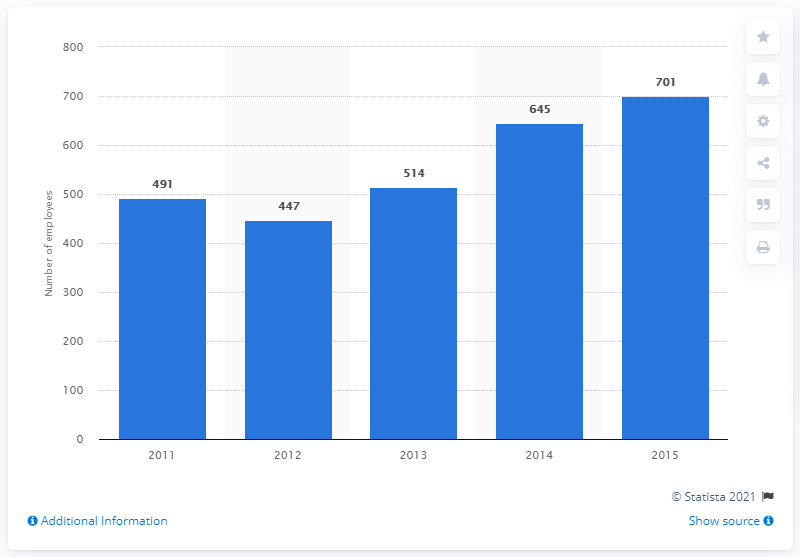Point out several critical features in this image. In 2015, Gianni Versace S.r.l. had 701 employees. 